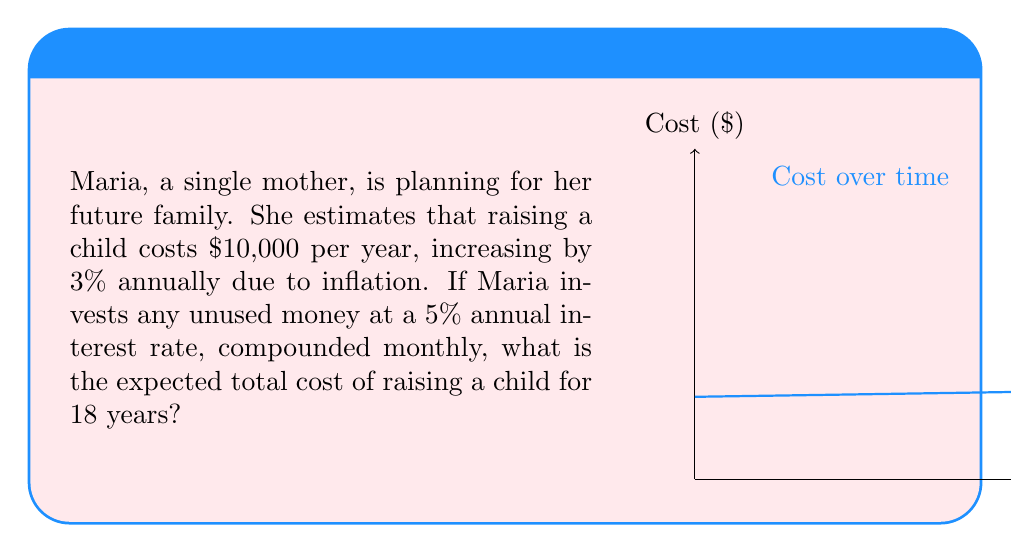Can you answer this question? Let's approach this step-by-step:

1) First, we need to calculate the cost for each year, considering the 3% annual increase:
   Year 1: $10,000
   Year 2: $10,000 * 1.03 = $10,300
   Year 3: $10,300 * 1.03 = $10,609
   ...and so on.

2) We can represent this with the formula: $C_n = 10000 * (1.03)^{n-1}$, where $C_n$ is the cost for year $n$.

3) Now, we need to consider the compound interest on the invested money. The monthly compound interest formula is:
   $A = P(1 + \frac{r}{12})^{12t}$
   where $A$ is the final amount, $P$ is the principal, $r$ is the annual interest rate, and $t$ is the time in years.

4) For each year, we need to calculate the present value (PV) of that year's cost. The PV formula is:
   $PV = \frac{FV}{(1 + \frac{r}{12})^{12t}}$
   where $FV$ is the future value (cost in our case).

5) Putting it all together, the total present value of the costs over 18 years is:

   $$\sum_{n=1}^{18} \frac{10000 * (1.03)^{n-1}}{(1 + \frac{0.05}{12})^{12n}}$$

6) Calculating this sum:
   Year 1: 9,762.60
   Year 2: 9,768.91
   ...
   Year 18: 10,062.89

7) The total sum of all these present values is approximately $179,816.54.
Answer: $179,816.54 